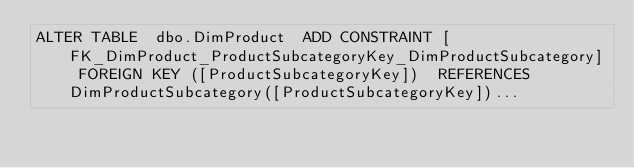Convert code to text. <code><loc_0><loc_0><loc_500><loc_500><_SQL_>ALTER TABLE  dbo.DimProduct  ADD CONSTRAINT [FK_DimProduct_ProductSubcategoryKey_DimProductSubcategory] FOREIGN KEY ([ProductSubcategoryKey])  REFERENCES DimProductSubcategory([ProductSubcategoryKey])...</code> 